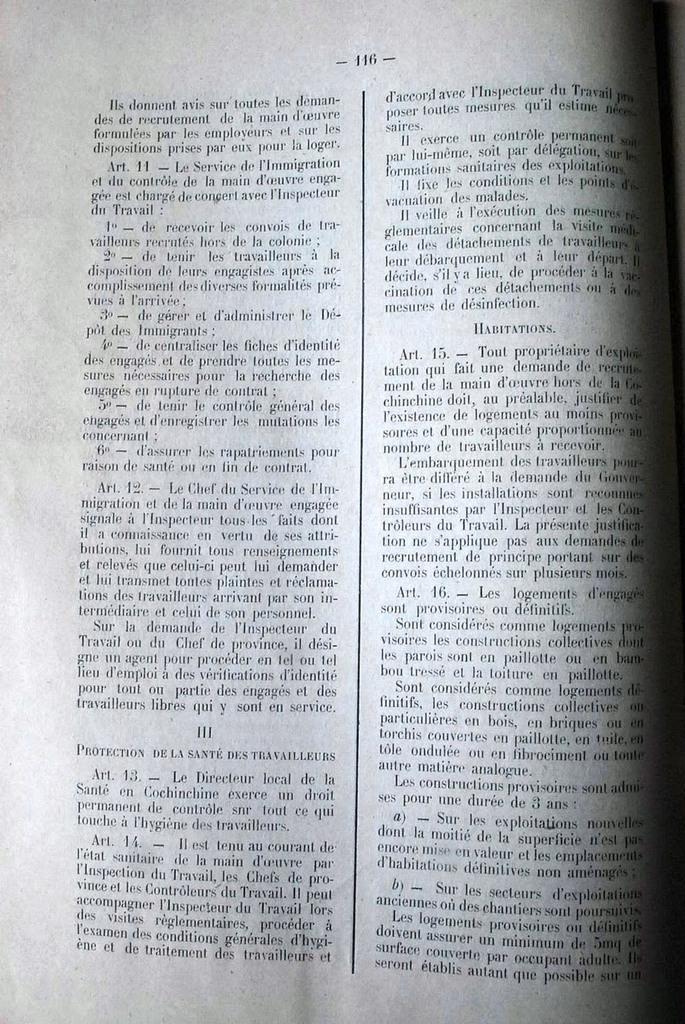In one or two sentences, can you explain what this image depicts? This is a page of the book, in it we can see the text. 